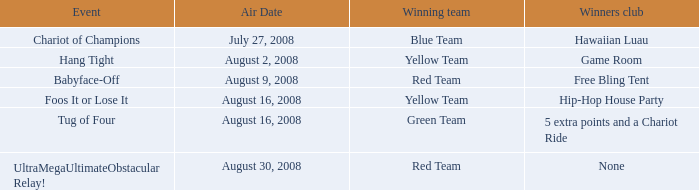How many weeks have a successful yellow team, and an occurrence of foos it or lose it? 4.0. 